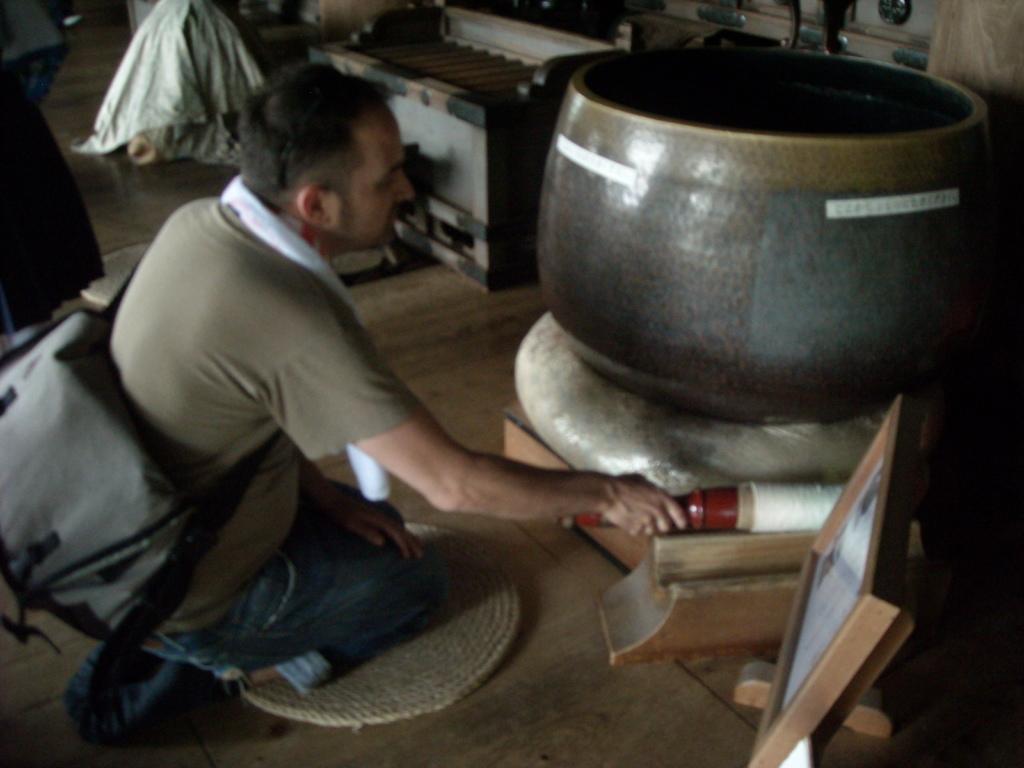Describe this image in one or two sentences. In this image we can see a person wearing a bag holding an object sitting on his knees on a mat beside a big container with a stand. We can also see some clothes, a wooden table and a frame beside him. 